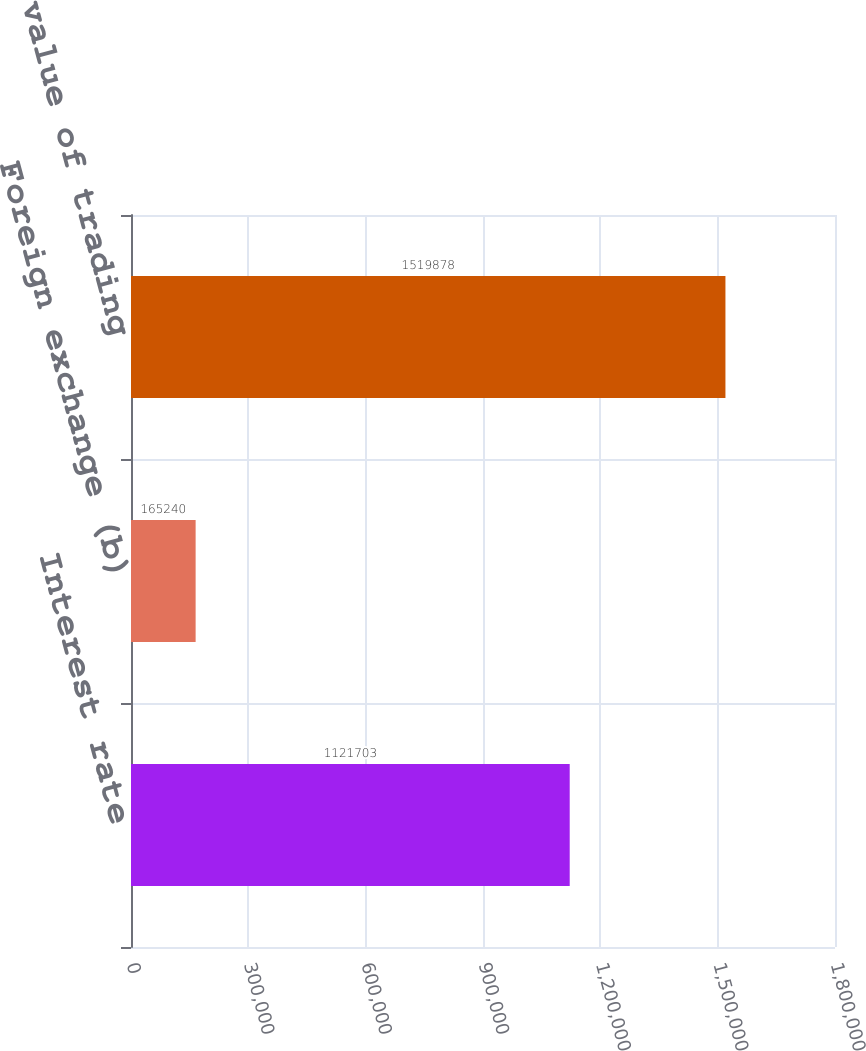Convert chart to OTSL. <chart><loc_0><loc_0><loc_500><loc_500><bar_chart><fcel>Interest rate<fcel>Foreign exchange (b)<fcel>Gross fair value of trading<nl><fcel>1.1217e+06<fcel>165240<fcel>1.51988e+06<nl></chart> 